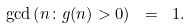<formula> <loc_0><loc_0><loc_500><loc_500>\gcd \left ( n \colon g ( n ) > 0 \right ) \ = \ 1 .</formula> 